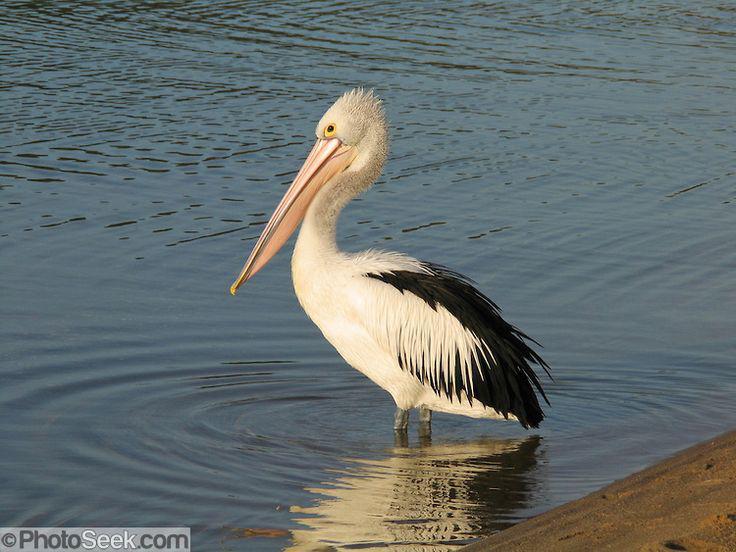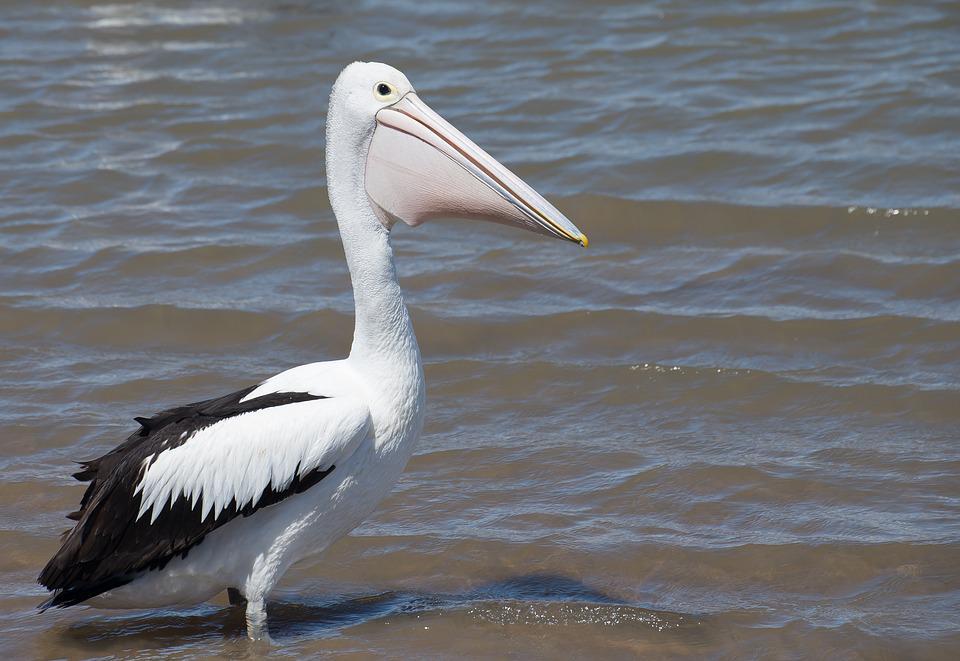The first image is the image on the left, the second image is the image on the right. Assess this claim about the two images: "One image depicts more than one water bird.". Correct or not? Answer yes or no. No. 